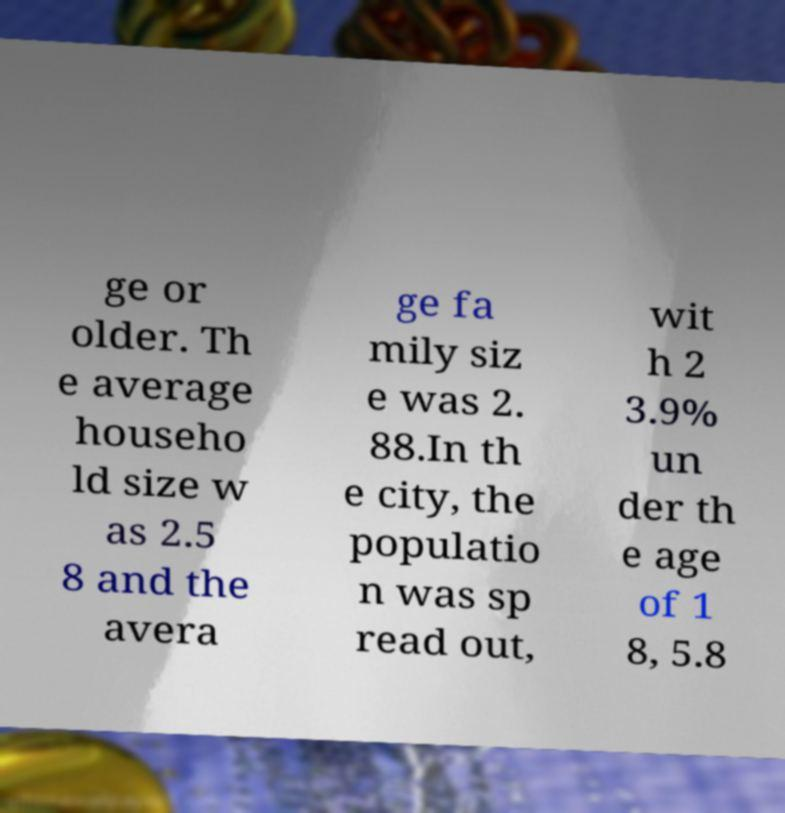There's text embedded in this image that I need extracted. Can you transcribe it verbatim? ge or older. Th e average househo ld size w as 2.5 8 and the avera ge fa mily siz e was 2. 88.In th e city, the populatio n was sp read out, wit h 2 3.9% un der th e age of 1 8, 5.8 